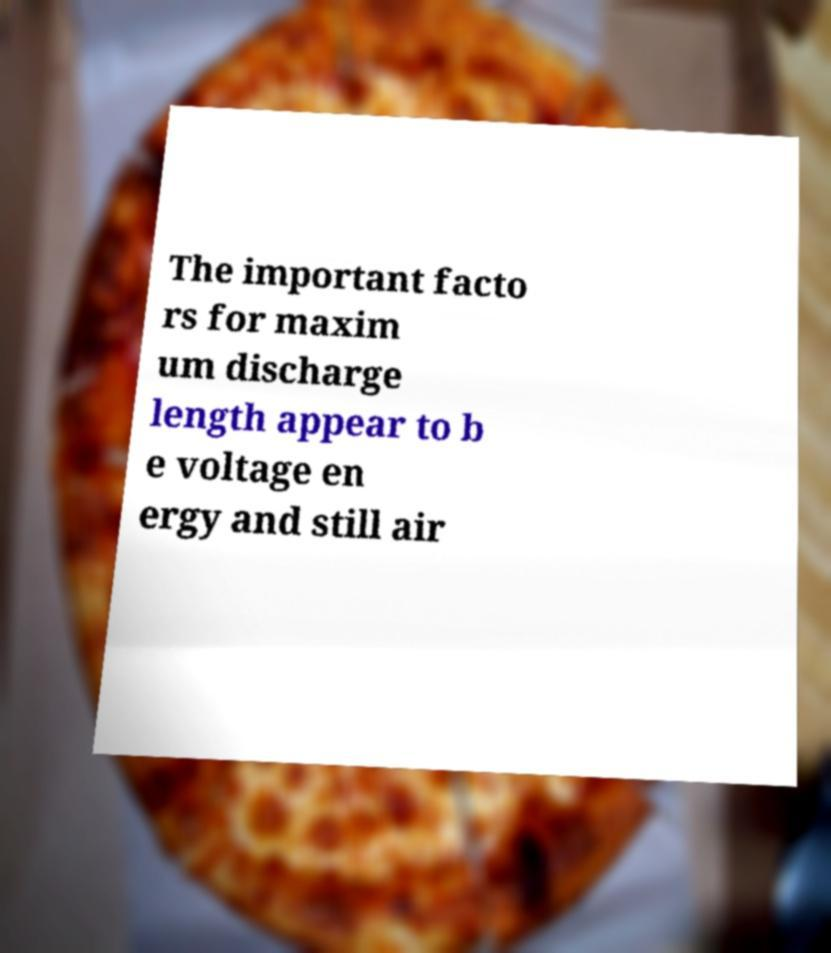What messages or text are displayed in this image? I need them in a readable, typed format. The important facto rs for maxim um discharge length appear to b e voltage en ergy and still air 